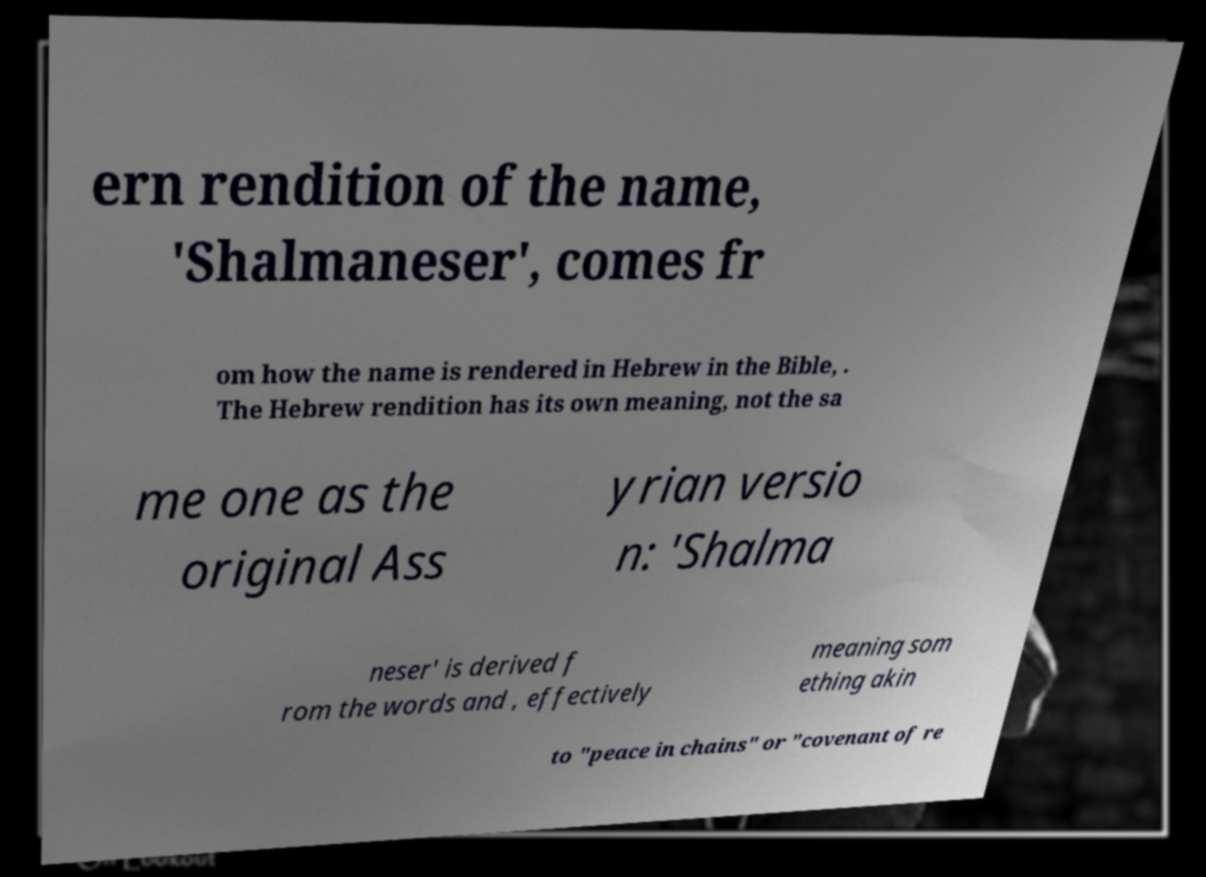Could you assist in decoding the text presented in this image and type it out clearly? ern rendition of the name, 'Shalmaneser', comes fr om how the name is rendered in Hebrew in the Bible, . The Hebrew rendition has its own meaning, not the sa me one as the original Ass yrian versio n: 'Shalma neser' is derived f rom the words and , effectively meaning som ething akin to "peace in chains" or "covenant of re 